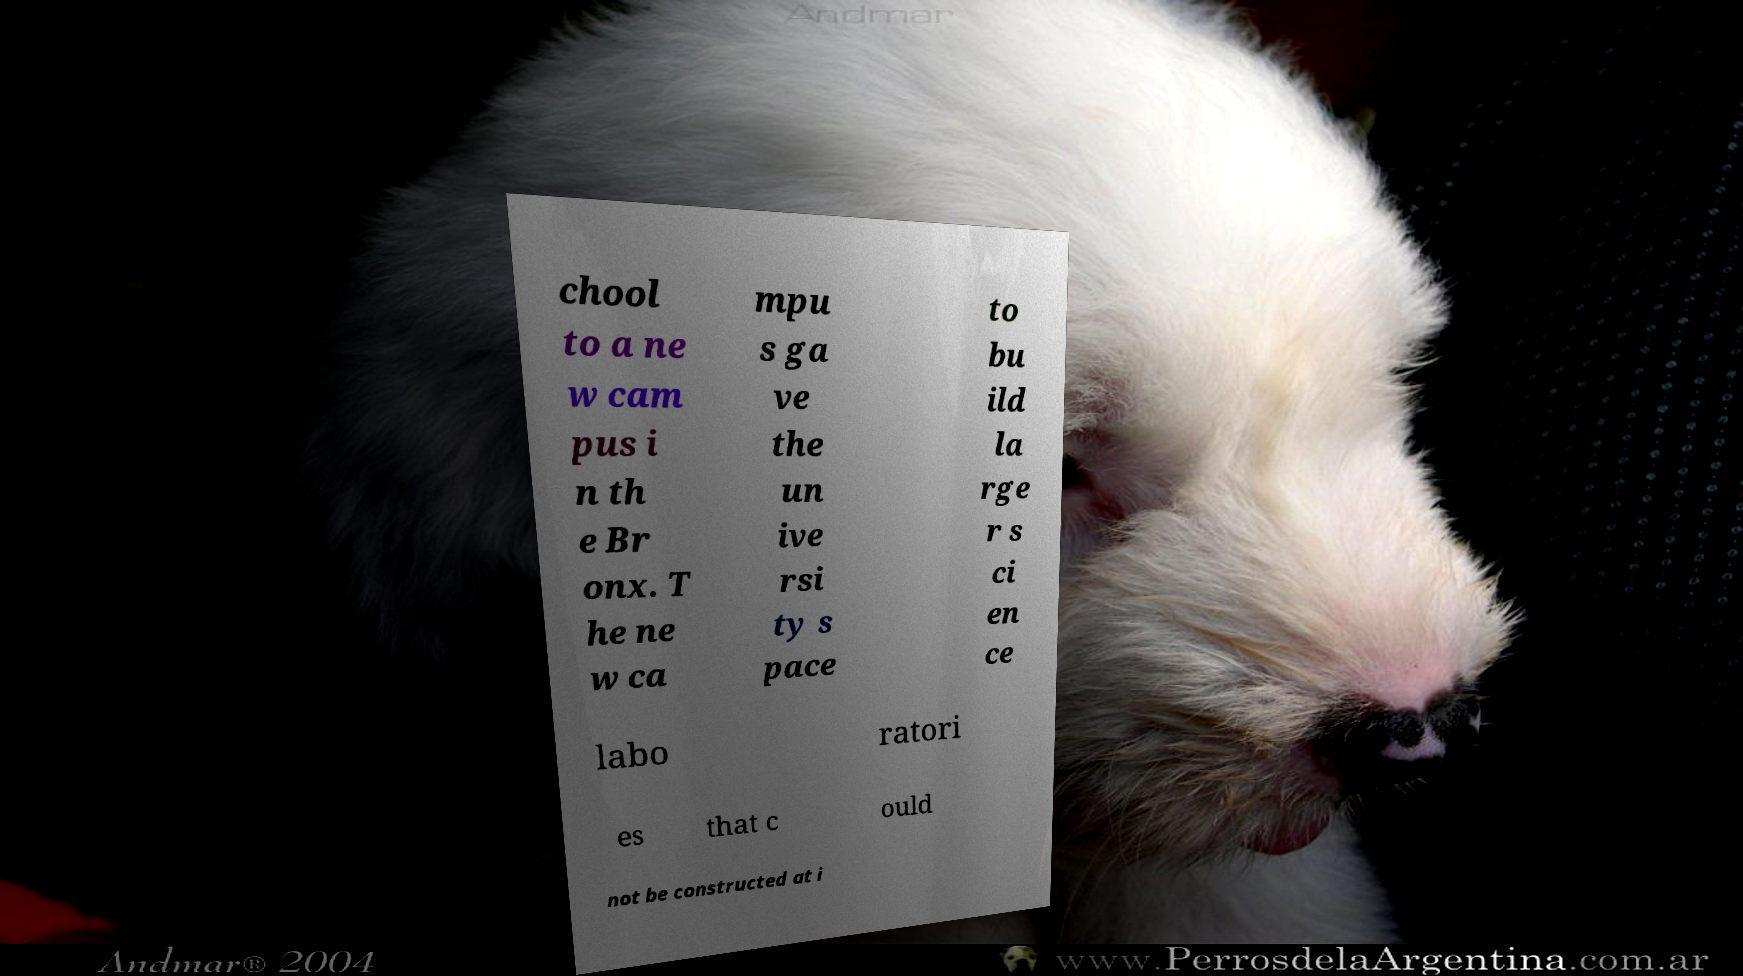Could you extract and type out the text from this image? chool to a ne w cam pus i n th e Br onx. T he ne w ca mpu s ga ve the un ive rsi ty s pace to bu ild la rge r s ci en ce labo ratori es that c ould not be constructed at i 